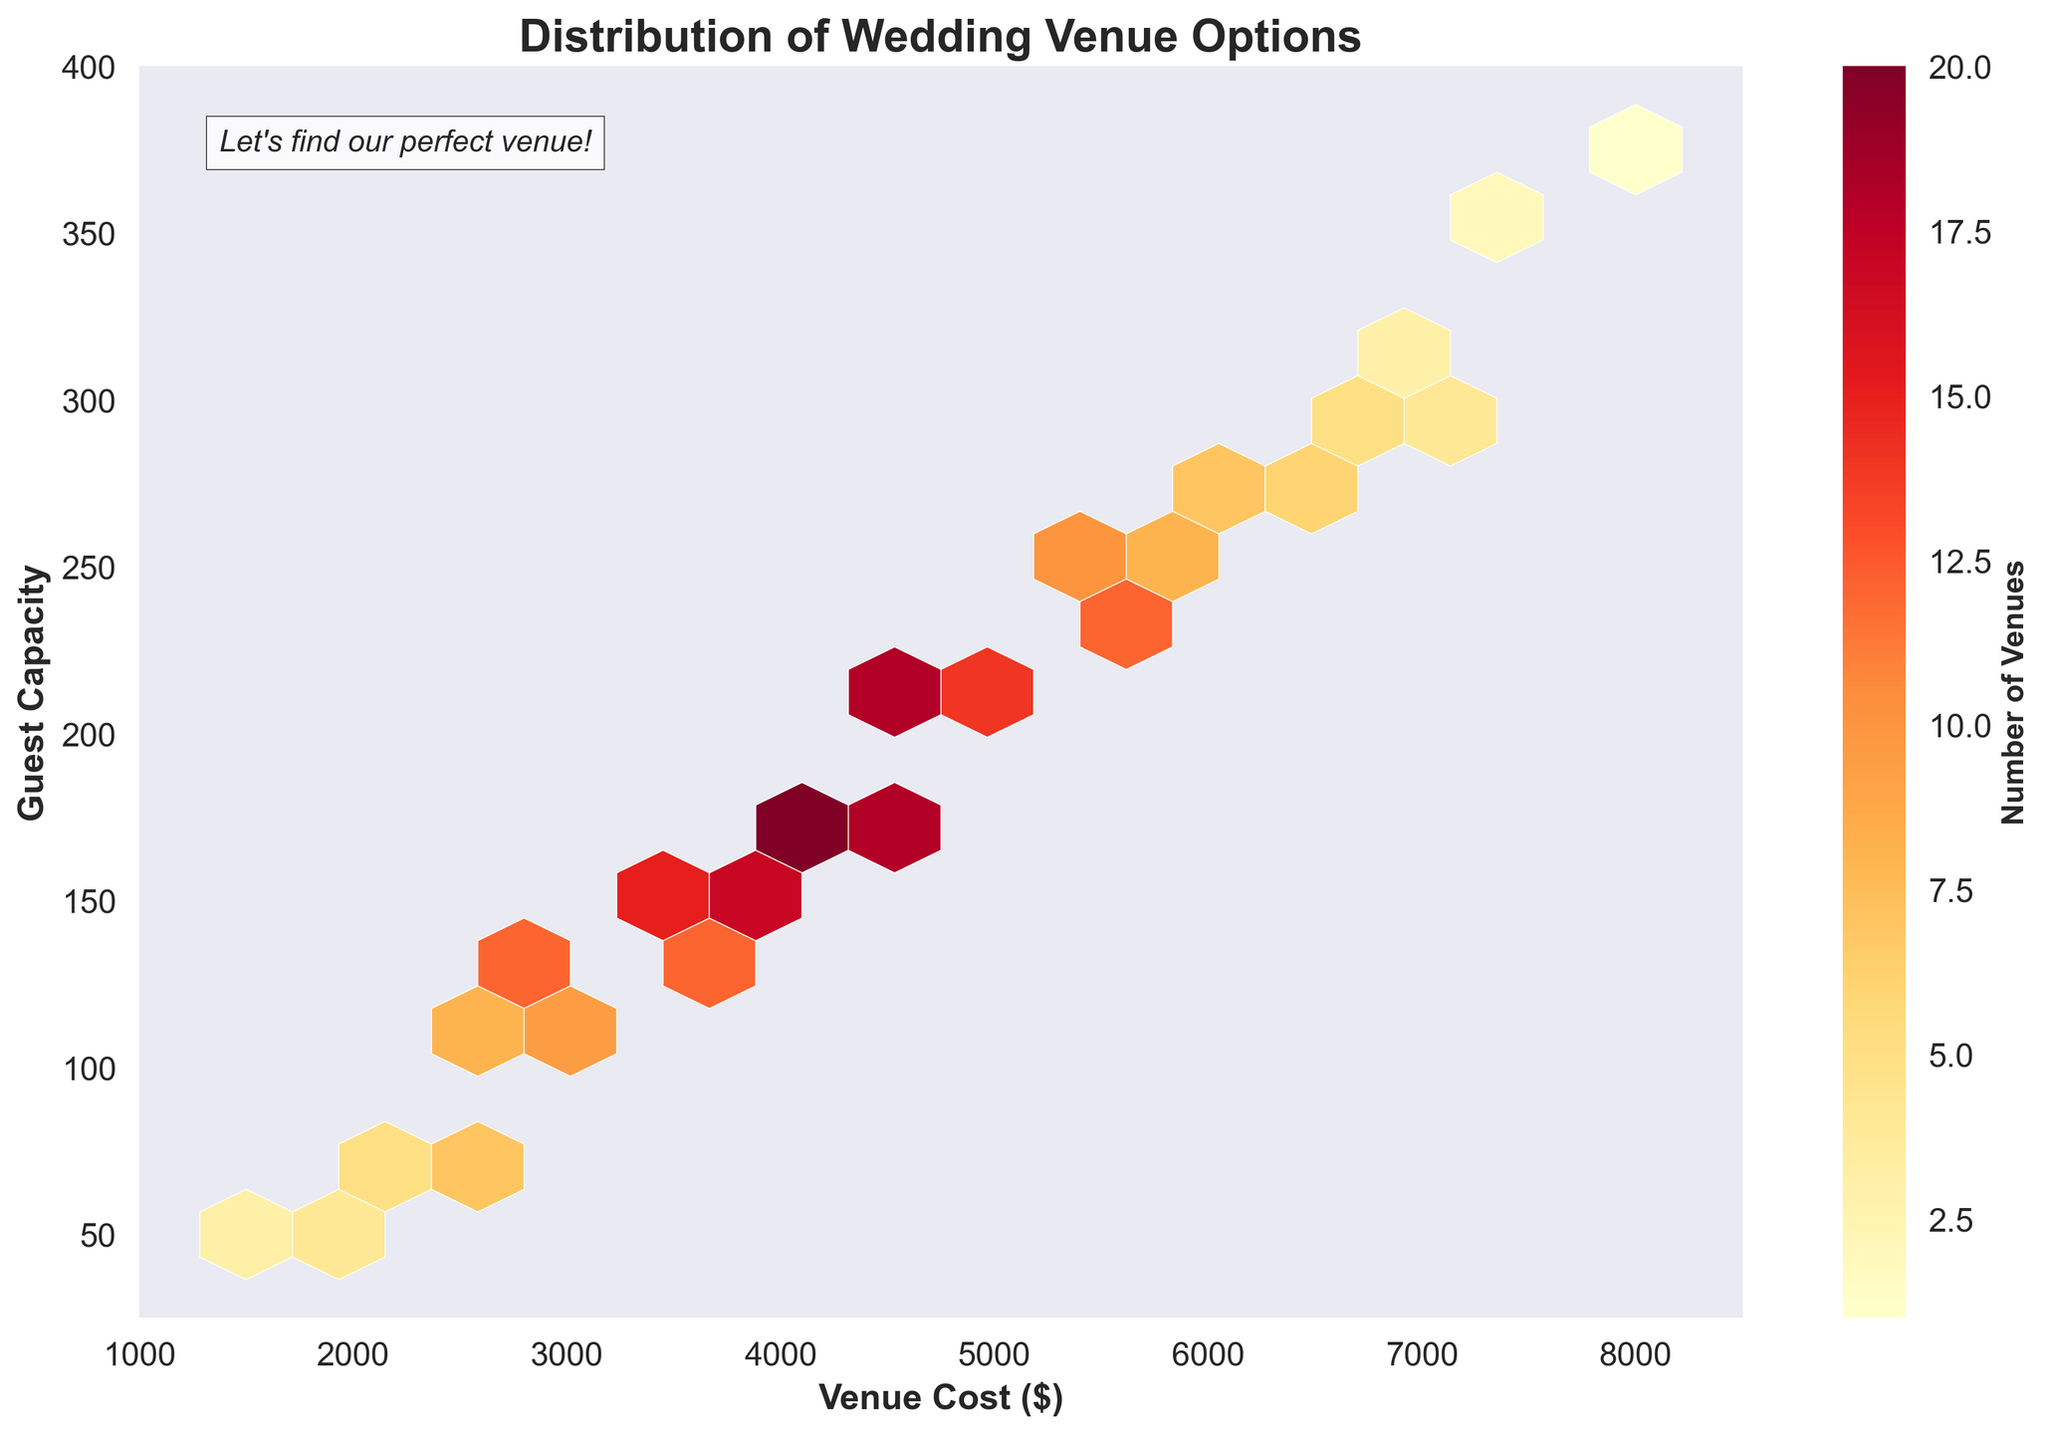How does the title of the plot relate to the data presented? The title of the plot is "Distribution of Wedding Venue Options". The data presented shows the distribution of wedding venue costs and their corresponding guest capacities, which are visualized using hexbin plotting techniques.
Answer: The title accurately describes the data What do the colors in the hexbin plot represent? The colors in the hexbin plot represent the number of venues available at different cost and guest capacity combinations. Warmer colors (like orange and red) indicate a higher concentration of venues.
Answer: Number of venues What is the range of venue costs displayed on the x-axis? The x-axis displays venue costs ranging from $1000 to $8500. This can be determined from the axis labels and limits set on the x-axis.
Answer: $1000 to $8500 Which guest capacity is associated with the highest number of venues? The hexagons around the 175 guest capacity mark are colored the most intensely, indicating that this is where the highest number of venues are concentrated.
Answer: 175 How does the number of venues change as venue cost increases from $2000 to $6000? As venue cost increases from $2000 to $6000, the number of venues initially increases, reaching a peak around the $4500 to $5000 range, and then gradually decreases. This pattern can be inferred from the changing coloration of the hexagons.
Answer: Increases then decreases What's the difference in the number of venues between the $\$3500$ and $\$2500$ cost levels, both at a guest capacity of 150? At a guest capacity of 150, the $3500 cost level has slightly more venues than the $2500 cost level as indicated by more intense coloring.
Answer: More at $3500 Between venue costs of $3000 and $5000, at what cost level do we find the largest number of venues for a capacity of 125 guests? For a capacity of 125 guests, the $3500 cost level shows the largest number of venues, as indicated by the more intense coloring at that coordinate.
Answer: $3500 What is the average guest capacity for venues costing $4000? Venues costing $4000 have hexagons spread around capacities of 150 and 200, so the average can be approximated to 175 guests.
Answer: Approximately 175 Do venues costing $7000 have higher or lower average guest capacities compared to those costing $5000? Venues costing $7000 are concentrated around a guest capacity of 300, which is higher than the venues costing $5000 (concentrated around 200-225).
Answer: Higher Where is the concentration of venues stronger, for costs $3000 to $4000 or costs $6000 to $7500? The concentration of venues is stronger between $3000 to $4000 compared to $6000 to $7500, as evidenced by the more intense coloring and higher number of hexagons in that range.
Answer: $3000 to $4000 